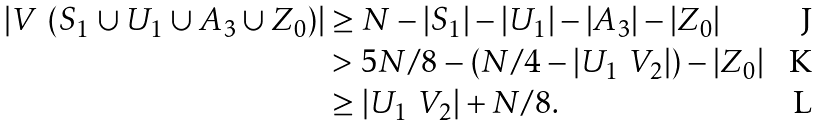Convert formula to latex. <formula><loc_0><loc_0><loc_500><loc_500>| V \ ( S _ { 1 } \cup U _ { 1 } \cup A _ { 3 } \cup Z _ { 0 } ) | & \geq N - | S _ { 1 } | - | U _ { 1 } | - | A _ { 3 } | - | Z _ { 0 } | \\ & > 5 N / 8 - ( N / 4 - | U _ { 1 } \ V _ { 2 } | ) - | Z _ { 0 } | \\ & \geq | U _ { 1 } \ V _ { 2 } | + N / 8 .</formula> 